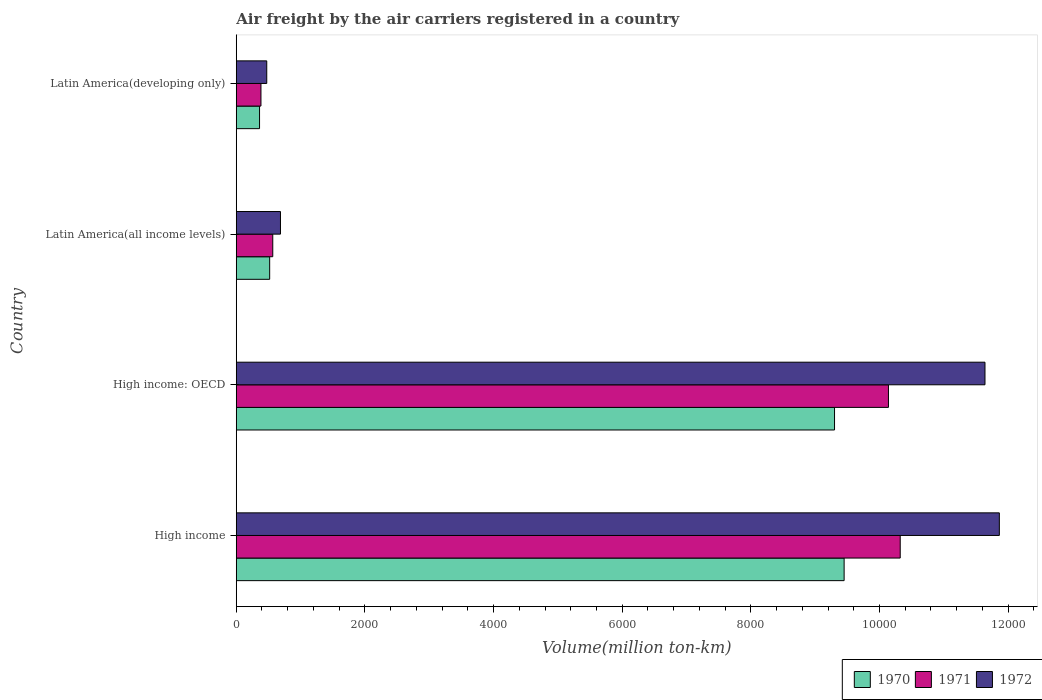How many groups of bars are there?
Provide a short and direct response. 4. Are the number of bars per tick equal to the number of legend labels?
Your response must be concise. Yes. How many bars are there on the 3rd tick from the bottom?
Your answer should be compact. 3. What is the label of the 1st group of bars from the top?
Your answer should be compact. Latin America(developing only). In how many cases, is the number of bars for a given country not equal to the number of legend labels?
Your response must be concise. 0. What is the volume of the air carriers in 1971 in Latin America(all income levels)?
Your answer should be very brief. 567.6. Across all countries, what is the maximum volume of the air carriers in 1970?
Make the answer very short. 9450. Across all countries, what is the minimum volume of the air carriers in 1971?
Your answer should be compact. 384. In which country was the volume of the air carriers in 1972 maximum?
Your answer should be compact. High income. In which country was the volume of the air carriers in 1972 minimum?
Offer a terse response. Latin America(developing only). What is the total volume of the air carriers in 1970 in the graph?
Give a very brief answer. 1.96e+04. What is the difference between the volume of the air carriers in 1972 in High income: OECD and that in Latin America(all income levels)?
Your answer should be very brief. 1.10e+04. What is the difference between the volume of the air carriers in 1971 in High income: OECD and the volume of the air carriers in 1970 in Latin America(developing only)?
Your answer should be compact. 9777.2. What is the average volume of the air carriers in 1972 per country?
Offer a very short reply. 6166.02. What is the difference between the volume of the air carriers in 1970 and volume of the air carriers in 1971 in High income: OECD?
Your response must be concise. -838.3. In how many countries, is the volume of the air carriers in 1972 greater than 11200 million ton-km?
Ensure brevity in your answer.  2. What is the ratio of the volume of the air carriers in 1971 in High income: OECD to that in Latin America(all income levels)?
Ensure brevity in your answer.  17.86. Is the volume of the air carriers in 1972 in High income less than that in Latin America(developing only)?
Provide a short and direct response. No. Is the difference between the volume of the air carriers in 1970 in High income and Latin America(all income levels) greater than the difference between the volume of the air carriers in 1971 in High income and Latin America(all income levels)?
Give a very brief answer. No. What is the difference between the highest and the second highest volume of the air carriers in 1970?
Your response must be concise. 149.1. What is the difference between the highest and the lowest volume of the air carriers in 1971?
Make the answer very short. 9937.9. What does the 3rd bar from the top in High income represents?
Keep it short and to the point. 1970. Is it the case that in every country, the sum of the volume of the air carriers in 1970 and volume of the air carriers in 1972 is greater than the volume of the air carriers in 1971?
Your answer should be compact. Yes. How many bars are there?
Your response must be concise. 12. How many countries are there in the graph?
Offer a terse response. 4. Does the graph contain any zero values?
Your response must be concise. No. Does the graph contain grids?
Offer a very short reply. No. How many legend labels are there?
Provide a succinct answer. 3. What is the title of the graph?
Your answer should be very brief. Air freight by the air carriers registered in a country. Does "1993" appear as one of the legend labels in the graph?
Ensure brevity in your answer.  No. What is the label or title of the X-axis?
Provide a short and direct response. Volume(million ton-km). What is the label or title of the Y-axis?
Your answer should be compact. Country. What is the Volume(million ton-km) in 1970 in High income?
Your response must be concise. 9450. What is the Volume(million ton-km) of 1971 in High income?
Give a very brief answer. 1.03e+04. What is the Volume(million ton-km) of 1972 in High income?
Provide a short and direct response. 1.19e+04. What is the Volume(million ton-km) of 1970 in High income: OECD?
Make the answer very short. 9300.9. What is the Volume(million ton-km) in 1971 in High income: OECD?
Provide a short and direct response. 1.01e+04. What is the Volume(million ton-km) of 1972 in High income: OECD?
Your answer should be compact. 1.16e+04. What is the Volume(million ton-km) in 1970 in Latin America(all income levels)?
Provide a short and direct response. 519.6. What is the Volume(million ton-km) of 1971 in Latin America(all income levels)?
Your answer should be very brief. 567.6. What is the Volume(million ton-km) in 1972 in Latin America(all income levels)?
Your answer should be compact. 687.4. What is the Volume(million ton-km) of 1970 in Latin America(developing only)?
Offer a terse response. 362. What is the Volume(million ton-km) of 1971 in Latin America(developing only)?
Provide a short and direct response. 384. What is the Volume(million ton-km) of 1972 in Latin America(developing only)?
Your answer should be compact. 474.1. Across all countries, what is the maximum Volume(million ton-km) in 1970?
Provide a short and direct response. 9450. Across all countries, what is the maximum Volume(million ton-km) in 1971?
Your answer should be very brief. 1.03e+04. Across all countries, what is the maximum Volume(million ton-km) in 1972?
Your response must be concise. 1.19e+04. Across all countries, what is the minimum Volume(million ton-km) of 1970?
Your answer should be compact. 362. Across all countries, what is the minimum Volume(million ton-km) of 1971?
Your answer should be very brief. 384. Across all countries, what is the minimum Volume(million ton-km) in 1972?
Offer a terse response. 474.1. What is the total Volume(million ton-km) of 1970 in the graph?
Your answer should be very brief. 1.96e+04. What is the total Volume(million ton-km) in 1971 in the graph?
Make the answer very short. 2.14e+04. What is the total Volume(million ton-km) in 1972 in the graph?
Your answer should be very brief. 2.47e+04. What is the difference between the Volume(million ton-km) in 1970 in High income and that in High income: OECD?
Your answer should be compact. 149.1. What is the difference between the Volume(million ton-km) in 1971 in High income and that in High income: OECD?
Offer a very short reply. 182.7. What is the difference between the Volume(million ton-km) of 1972 in High income and that in High income: OECD?
Provide a short and direct response. 223.2. What is the difference between the Volume(million ton-km) in 1970 in High income and that in Latin America(all income levels)?
Your answer should be very brief. 8930.4. What is the difference between the Volume(million ton-km) of 1971 in High income and that in Latin America(all income levels)?
Offer a terse response. 9754.3. What is the difference between the Volume(million ton-km) in 1972 in High income and that in Latin America(all income levels)?
Keep it short and to the point. 1.12e+04. What is the difference between the Volume(million ton-km) of 1970 in High income and that in Latin America(developing only)?
Your answer should be very brief. 9088. What is the difference between the Volume(million ton-km) in 1971 in High income and that in Latin America(developing only)?
Keep it short and to the point. 9937.9. What is the difference between the Volume(million ton-km) of 1972 in High income and that in Latin America(developing only)?
Provide a short and direct response. 1.14e+04. What is the difference between the Volume(million ton-km) of 1970 in High income: OECD and that in Latin America(all income levels)?
Ensure brevity in your answer.  8781.3. What is the difference between the Volume(million ton-km) in 1971 in High income: OECD and that in Latin America(all income levels)?
Provide a short and direct response. 9571.6. What is the difference between the Volume(million ton-km) of 1972 in High income: OECD and that in Latin America(all income levels)?
Provide a short and direct response. 1.10e+04. What is the difference between the Volume(million ton-km) of 1970 in High income: OECD and that in Latin America(developing only)?
Your answer should be very brief. 8938.9. What is the difference between the Volume(million ton-km) of 1971 in High income: OECD and that in Latin America(developing only)?
Offer a very short reply. 9755.2. What is the difference between the Volume(million ton-km) in 1972 in High income: OECD and that in Latin America(developing only)?
Your response must be concise. 1.12e+04. What is the difference between the Volume(million ton-km) of 1970 in Latin America(all income levels) and that in Latin America(developing only)?
Keep it short and to the point. 157.6. What is the difference between the Volume(million ton-km) in 1971 in Latin America(all income levels) and that in Latin America(developing only)?
Provide a short and direct response. 183.6. What is the difference between the Volume(million ton-km) of 1972 in Latin America(all income levels) and that in Latin America(developing only)?
Make the answer very short. 213.3. What is the difference between the Volume(million ton-km) of 1970 in High income and the Volume(million ton-km) of 1971 in High income: OECD?
Offer a terse response. -689.2. What is the difference between the Volume(million ton-km) of 1970 in High income and the Volume(million ton-km) of 1972 in High income: OECD?
Your answer should be compact. -2189.7. What is the difference between the Volume(million ton-km) in 1971 in High income and the Volume(million ton-km) in 1972 in High income: OECD?
Your answer should be compact. -1317.8. What is the difference between the Volume(million ton-km) of 1970 in High income and the Volume(million ton-km) of 1971 in Latin America(all income levels)?
Make the answer very short. 8882.4. What is the difference between the Volume(million ton-km) of 1970 in High income and the Volume(million ton-km) of 1972 in Latin America(all income levels)?
Provide a succinct answer. 8762.6. What is the difference between the Volume(million ton-km) in 1971 in High income and the Volume(million ton-km) in 1972 in Latin America(all income levels)?
Make the answer very short. 9634.5. What is the difference between the Volume(million ton-km) in 1970 in High income and the Volume(million ton-km) in 1971 in Latin America(developing only)?
Your answer should be very brief. 9066. What is the difference between the Volume(million ton-km) of 1970 in High income and the Volume(million ton-km) of 1972 in Latin America(developing only)?
Provide a short and direct response. 8975.9. What is the difference between the Volume(million ton-km) of 1971 in High income and the Volume(million ton-km) of 1972 in Latin America(developing only)?
Keep it short and to the point. 9847.8. What is the difference between the Volume(million ton-km) of 1970 in High income: OECD and the Volume(million ton-km) of 1971 in Latin America(all income levels)?
Provide a short and direct response. 8733.3. What is the difference between the Volume(million ton-km) in 1970 in High income: OECD and the Volume(million ton-km) in 1972 in Latin America(all income levels)?
Provide a succinct answer. 8613.5. What is the difference between the Volume(million ton-km) in 1971 in High income: OECD and the Volume(million ton-km) in 1972 in Latin America(all income levels)?
Keep it short and to the point. 9451.8. What is the difference between the Volume(million ton-km) of 1970 in High income: OECD and the Volume(million ton-km) of 1971 in Latin America(developing only)?
Offer a very short reply. 8916.9. What is the difference between the Volume(million ton-km) in 1970 in High income: OECD and the Volume(million ton-km) in 1972 in Latin America(developing only)?
Give a very brief answer. 8826.8. What is the difference between the Volume(million ton-km) in 1971 in High income: OECD and the Volume(million ton-km) in 1972 in Latin America(developing only)?
Make the answer very short. 9665.1. What is the difference between the Volume(million ton-km) of 1970 in Latin America(all income levels) and the Volume(million ton-km) of 1971 in Latin America(developing only)?
Give a very brief answer. 135.6. What is the difference between the Volume(million ton-km) in 1970 in Latin America(all income levels) and the Volume(million ton-km) in 1972 in Latin America(developing only)?
Offer a terse response. 45.5. What is the difference between the Volume(million ton-km) of 1971 in Latin America(all income levels) and the Volume(million ton-km) of 1972 in Latin America(developing only)?
Offer a terse response. 93.5. What is the average Volume(million ton-km) of 1970 per country?
Offer a terse response. 4908.13. What is the average Volume(million ton-km) of 1971 per country?
Offer a very short reply. 5353.17. What is the average Volume(million ton-km) in 1972 per country?
Ensure brevity in your answer.  6166.02. What is the difference between the Volume(million ton-km) of 1970 and Volume(million ton-km) of 1971 in High income?
Your answer should be very brief. -871.9. What is the difference between the Volume(million ton-km) in 1970 and Volume(million ton-km) in 1972 in High income?
Make the answer very short. -2412.9. What is the difference between the Volume(million ton-km) of 1971 and Volume(million ton-km) of 1972 in High income?
Your answer should be compact. -1541. What is the difference between the Volume(million ton-km) in 1970 and Volume(million ton-km) in 1971 in High income: OECD?
Keep it short and to the point. -838.3. What is the difference between the Volume(million ton-km) in 1970 and Volume(million ton-km) in 1972 in High income: OECD?
Your answer should be compact. -2338.8. What is the difference between the Volume(million ton-km) of 1971 and Volume(million ton-km) of 1972 in High income: OECD?
Your response must be concise. -1500.5. What is the difference between the Volume(million ton-km) of 1970 and Volume(million ton-km) of 1971 in Latin America(all income levels)?
Offer a terse response. -48. What is the difference between the Volume(million ton-km) in 1970 and Volume(million ton-km) in 1972 in Latin America(all income levels)?
Offer a terse response. -167.8. What is the difference between the Volume(million ton-km) in 1971 and Volume(million ton-km) in 1972 in Latin America(all income levels)?
Ensure brevity in your answer.  -119.8. What is the difference between the Volume(million ton-km) in 1970 and Volume(million ton-km) in 1971 in Latin America(developing only)?
Your answer should be compact. -22. What is the difference between the Volume(million ton-km) in 1970 and Volume(million ton-km) in 1972 in Latin America(developing only)?
Offer a terse response. -112.1. What is the difference between the Volume(million ton-km) in 1971 and Volume(million ton-km) in 1972 in Latin America(developing only)?
Your answer should be very brief. -90.1. What is the ratio of the Volume(million ton-km) in 1972 in High income to that in High income: OECD?
Offer a terse response. 1.02. What is the ratio of the Volume(million ton-km) of 1970 in High income to that in Latin America(all income levels)?
Your answer should be very brief. 18.19. What is the ratio of the Volume(million ton-km) of 1971 in High income to that in Latin America(all income levels)?
Keep it short and to the point. 18.19. What is the ratio of the Volume(million ton-km) in 1972 in High income to that in Latin America(all income levels)?
Give a very brief answer. 17.26. What is the ratio of the Volume(million ton-km) in 1970 in High income to that in Latin America(developing only)?
Make the answer very short. 26.11. What is the ratio of the Volume(million ton-km) in 1971 in High income to that in Latin America(developing only)?
Your answer should be compact. 26.88. What is the ratio of the Volume(million ton-km) of 1972 in High income to that in Latin America(developing only)?
Offer a terse response. 25.02. What is the ratio of the Volume(million ton-km) of 1970 in High income: OECD to that in Latin America(all income levels)?
Make the answer very short. 17.9. What is the ratio of the Volume(million ton-km) of 1971 in High income: OECD to that in Latin America(all income levels)?
Your response must be concise. 17.86. What is the ratio of the Volume(million ton-km) in 1972 in High income: OECD to that in Latin America(all income levels)?
Your response must be concise. 16.93. What is the ratio of the Volume(million ton-km) of 1970 in High income: OECD to that in Latin America(developing only)?
Your response must be concise. 25.69. What is the ratio of the Volume(million ton-km) of 1971 in High income: OECD to that in Latin America(developing only)?
Give a very brief answer. 26.4. What is the ratio of the Volume(million ton-km) in 1972 in High income: OECD to that in Latin America(developing only)?
Your answer should be very brief. 24.55. What is the ratio of the Volume(million ton-km) of 1970 in Latin America(all income levels) to that in Latin America(developing only)?
Your response must be concise. 1.44. What is the ratio of the Volume(million ton-km) in 1971 in Latin America(all income levels) to that in Latin America(developing only)?
Provide a short and direct response. 1.48. What is the ratio of the Volume(million ton-km) of 1972 in Latin America(all income levels) to that in Latin America(developing only)?
Your answer should be compact. 1.45. What is the difference between the highest and the second highest Volume(million ton-km) in 1970?
Your response must be concise. 149.1. What is the difference between the highest and the second highest Volume(million ton-km) in 1971?
Provide a short and direct response. 182.7. What is the difference between the highest and the second highest Volume(million ton-km) of 1972?
Your answer should be compact. 223.2. What is the difference between the highest and the lowest Volume(million ton-km) in 1970?
Make the answer very short. 9088. What is the difference between the highest and the lowest Volume(million ton-km) in 1971?
Your response must be concise. 9937.9. What is the difference between the highest and the lowest Volume(million ton-km) in 1972?
Your answer should be compact. 1.14e+04. 